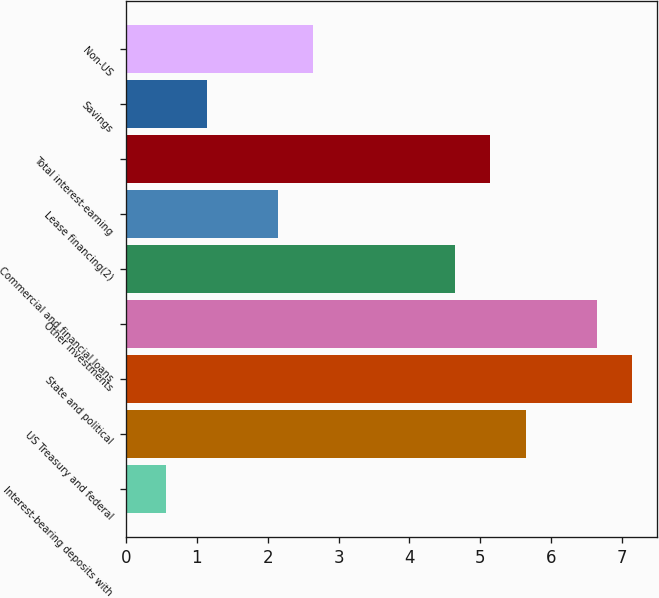Convert chart to OTSL. <chart><loc_0><loc_0><loc_500><loc_500><bar_chart><fcel>Interest-bearing deposits with<fcel>US Treasury and federal<fcel>State and political<fcel>Other investments<fcel>Commercial and financial loans<fcel>Lease financing(2)<fcel>Total interest-earning<fcel>Savings<fcel>Non-US<nl><fcel>0.56<fcel>5.64<fcel>7.14<fcel>6.64<fcel>4.64<fcel>2.14<fcel>5.14<fcel>1.14<fcel>2.64<nl></chart> 